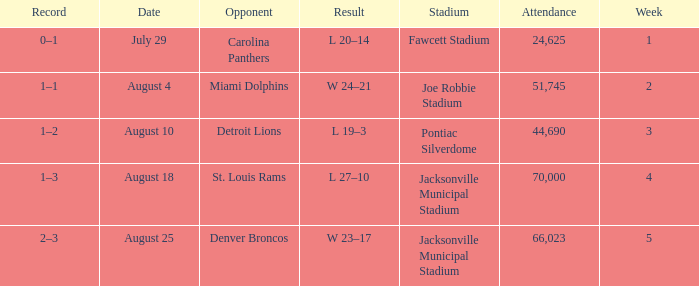What is the Record in Week 2? 1–1. 